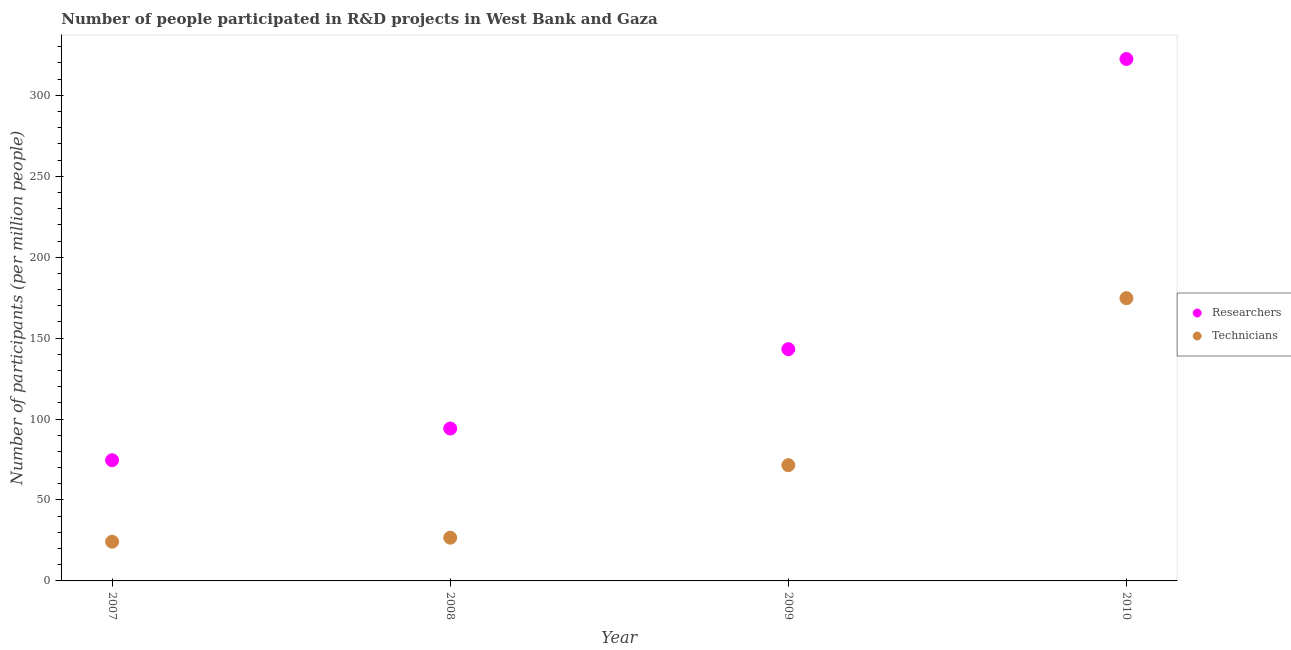What is the number of technicians in 2010?
Provide a short and direct response. 174.68. Across all years, what is the maximum number of researchers?
Keep it short and to the point. 322.46. Across all years, what is the minimum number of researchers?
Your response must be concise. 74.57. In which year was the number of researchers minimum?
Provide a short and direct response. 2007. What is the total number of technicians in the graph?
Your response must be concise. 297.16. What is the difference between the number of technicians in 2008 and that in 2009?
Your answer should be compact. -44.8. What is the difference between the number of technicians in 2007 and the number of researchers in 2009?
Make the answer very short. -118.95. What is the average number of technicians per year?
Offer a terse response. 74.29. In the year 2008, what is the difference between the number of researchers and number of technicians?
Keep it short and to the point. 67.45. In how many years, is the number of technicians greater than 290?
Ensure brevity in your answer.  0. What is the ratio of the number of technicians in 2007 to that in 2009?
Provide a succinct answer. 0.34. Is the number of researchers in 2008 less than that in 2009?
Your answer should be compact. Yes. Is the difference between the number of researchers in 2009 and 2010 greater than the difference between the number of technicians in 2009 and 2010?
Provide a short and direct response. No. What is the difference between the highest and the second highest number of researchers?
Your answer should be compact. 179.27. What is the difference between the highest and the lowest number of researchers?
Offer a terse response. 247.88. In how many years, is the number of technicians greater than the average number of technicians taken over all years?
Your answer should be very brief. 1. Is the number of researchers strictly greater than the number of technicians over the years?
Make the answer very short. Yes. Is the number of technicians strictly less than the number of researchers over the years?
Ensure brevity in your answer.  Yes. How many dotlines are there?
Your answer should be very brief. 2. Are the values on the major ticks of Y-axis written in scientific E-notation?
Provide a short and direct response. No. Does the graph contain any zero values?
Offer a very short reply. No. Where does the legend appear in the graph?
Provide a succinct answer. Center right. How are the legend labels stacked?
Your answer should be very brief. Vertical. What is the title of the graph?
Provide a succinct answer. Number of people participated in R&D projects in West Bank and Gaza. What is the label or title of the X-axis?
Your answer should be very brief. Year. What is the label or title of the Y-axis?
Offer a terse response. Number of participants (per million people). What is the Number of participants (per million people) in Researchers in 2007?
Ensure brevity in your answer.  74.57. What is the Number of participants (per million people) of Technicians in 2007?
Provide a short and direct response. 24.24. What is the Number of participants (per million people) in Researchers in 2008?
Keep it short and to the point. 94.17. What is the Number of participants (per million people) in Technicians in 2008?
Ensure brevity in your answer.  26.72. What is the Number of participants (per million people) in Researchers in 2009?
Give a very brief answer. 143.18. What is the Number of participants (per million people) in Technicians in 2009?
Make the answer very short. 71.52. What is the Number of participants (per million people) in Researchers in 2010?
Offer a terse response. 322.46. What is the Number of participants (per million people) in Technicians in 2010?
Your response must be concise. 174.68. Across all years, what is the maximum Number of participants (per million people) in Researchers?
Provide a succinct answer. 322.46. Across all years, what is the maximum Number of participants (per million people) in Technicians?
Offer a terse response. 174.68. Across all years, what is the minimum Number of participants (per million people) of Researchers?
Your answer should be very brief. 74.57. Across all years, what is the minimum Number of participants (per million people) of Technicians?
Your answer should be compact. 24.24. What is the total Number of participants (per million people) in Researchers in the graph?
Your answer should be very brief. 634.38. What is the total Number of participants (per million people) of Technicians in the graph?
Your answer should be compact. 297.16. What is the difference between the Number of participants (per million people) of Researchers in 2007 and that in 2008?
Your answer should be very brief. -19.6. What is the difference between the Number of participants (per million people) in Technicians in 2007 and that in 2008?
Your response must be concise. -2.48. What is the difference between the Number of participants (per million people) in Researchers in 2007 and that in 2009?
Keep it short and to the point. -68.61. What is the difference between the Number of participants (per million people) in Technicians in 2007 and that in 2009?
Your answer should be very brief. -47.28. What is the difference between the Number of participants (per million people) in Researchers in 2007 and that in 2010?
Ensure brevity in your answer.  -247.88. What is the difference between the Number of participants (per million people) of Technicians in 2007 and that in 2010?
Provide a short and direct response. -150.44. What is the difference between the Number of participants (per million people) of Researchers in 2008 and that in 2009?
Your answer should be compact. -49.01. What is the difference between the Number of participants (per million people) in Technicians in 2008 and that in 2009?
Ensure brevity in your answer.  -44.8. What is the difference between the Number of participants (per million people) in Researchers in 2008 and that in 2010?
Offer a terse response. -228.28. What is the difference between the Number of participants (per million people) in Technicians in 2008 and that in 2010?
Your answer should be compact. -147.96. What is the difference between the Number of participants (per million people) in Researchers in 2009 and that in 2010?
Your answer should be very brief. -179.27. What is the difference between the Number of participants (per million people) in Technicians in 2009 and that in 2010?
Provide a short and direct response. -103.16. What is the difference between the Number of participants (per million people) of Researchers in 2007 and the Number of participants (per million people) of Technicians in 2008?
Provide a short and direct response. 47.85. What is the difference between the Number of participants (per million people) of Researchers in 2007 and the Number of participants (per million people) of Technicians in 2009?
Make the answer very short. 3.05. What is the difference between the Number of participants (per million people) in Researchers in 2007 and the Number of participants (per million people) in Technicians in 2010?
Give a very brief answer. -100.11. What is the difference between the Number of participants (per million people) of Researchers in 2008 and the Number of participants (per million people) of Technicians in 2009?
Provide a short and direct response. 22.65. What is the difference between the Number of participants (per million people) of Researchers in 2008 and the Number of participants (per million people) of Technicians in 2010?
Give a very brief answer. -80.51. What is the difference between the Number of participants (per million people) of Researchers in 2009 and the Number of participants (per million people) of Technicians in 2010?
Your answer should be compact. -31.5. What is the average Number of participants (per million people) in Researchers per year?
Your answer should be very brief. 158.6. What is the average Number of participants (per million people) in Technicians per year?
Offer a very short reply. 74.29. In the year 2007, what is the difference between the Number of participants (per million people) in Researchers and Number of participants (per million people) in Technicians?
Your answer should be very brief. 50.34. In the year 2008, what is the difference between the Number of participants (per million people) in Researchers and Number of participants (per million people) in Technicians?
Your answer should be very brief. 67.45. In the year 2009, what is the difference between the Number of participants (per million people) in Researchers and Number of participants (per million people) in Technicians?
Make the answer very short. 71.66. In the year 2010, what is the difference between the Number of participants (per million people) of Researchers and Number of participants (per million people) of Technicians?
Keep it short and to the point. 147.77. What is the ratio of the Number of participants (per million people) of Researchers in 2007 to that in 2008?
Your answer should be very brief. 0.79. What is the ratio of the Number of participants (per million people) of Technicians in 2007 to that in 2008?
Your response must be concise. 0.91. What is the ratio of the Number of participants (per million people) in Researchers in 2007 to that in 2009?
Your answer should be very brief. 0.52. What is the ratio of the Number of participants (per million people) of Technicians in 2007 to that in 2009?
Provide a succinct answer. 0.34. What is the ratio of the Number of participants (per million people) in Researchers in 2007 to that in 2010?
Offer a terse response. 0.23. What is the ratio of the Number of participants (per million people) of Technicians in 2007 to that in 2010?
Give a very brief answer. 0.14. What is the ratio of the Number of participants (per million people) of Researchers in 2008 to that in 2009?
Provide a short and direct response. 0.66. What is the ratio of the Number of participants (per million people) of Technicians in 2008 to that in 2009?
Make the answer very short. 0.37. What is the ratio of the Number of participants (per million people) in Researchers in 2008 to that in 2010?
Offer a very short reply. 0.29. What is the ratio of the Number of participants (per million people) of Technicians in 2008 to that in 2010?
Provide a short and direct response. 0.15. What is the ratio of the Number of participants (per million people) of Researchers in 2009 to that in 2010?
Offer a terse response. 0.44. What is the ratio of the Number of participants (per million people) in Technicians in 2009 to that in 2010?
Make the answer very short. 0.41. What is the difference between the highest and the second highest Number of participants (per million people) of Researchers?
Your answer should be very brief. 179.27. What is the difference between the highest and the second highest Number of participants (per million people) in Technicians?
Your answer should be compact. 103.16. What is the difference between the highest and the lowest Number of participants (per million people) in Researchers?
Your answer should be very brief. 247.88. What is the difference between the highest and the lowest Number of participants (per million people) in Technicians?
Your response must be concise. 150.44. 